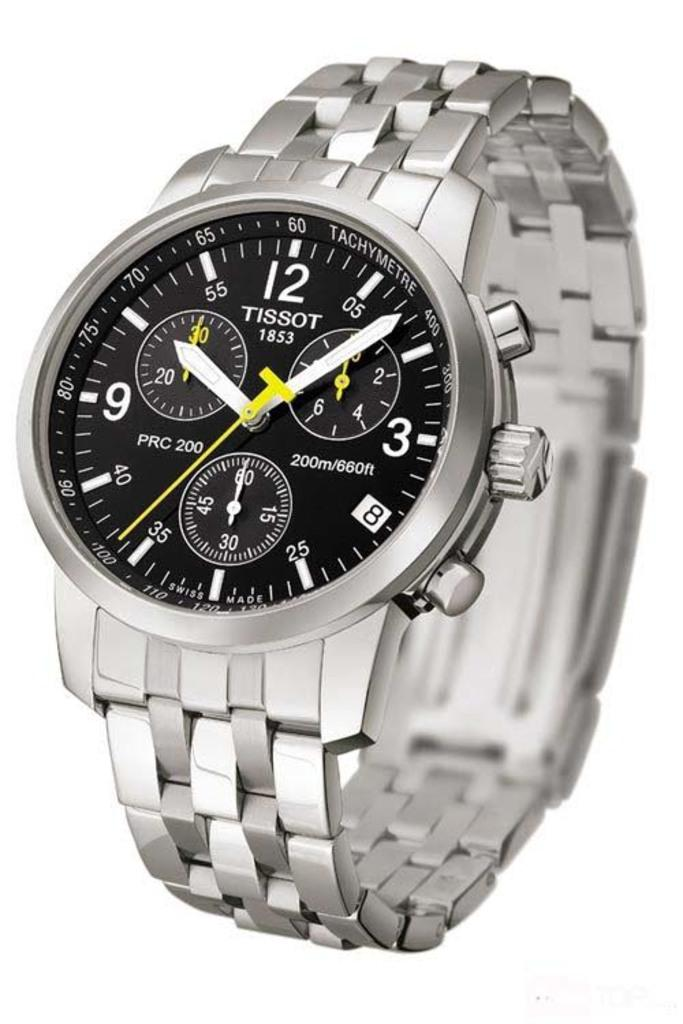Provide a one-sentence caption for the provided image. a Tissot 1853 analog silver watch with black face. 